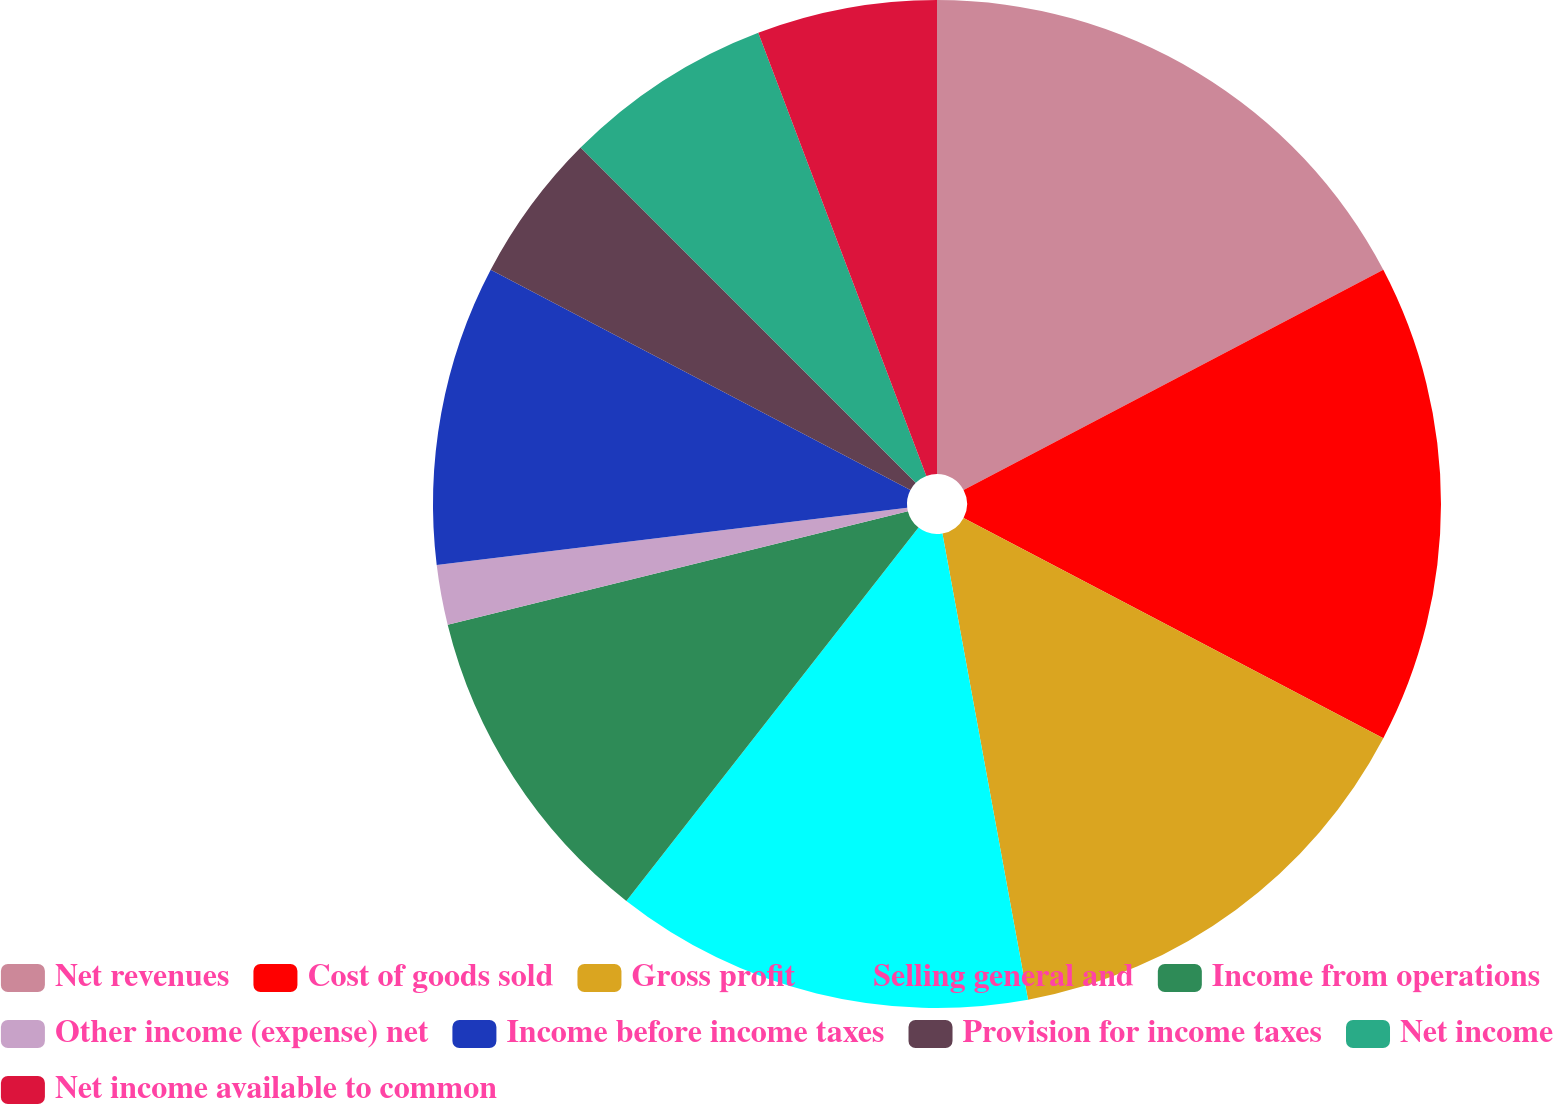<chart> <loc_0><loc_0><loc_500><loc_500><pie_chart><fcel>Net revenues<fcel>Cost of goods sold<fcel>Gross profit<fcel>Selling general and<fcel>Income from operations<fcel>Other income (expense) net<fcel>Income before income taxes<fcel>Provision for income taxes<fcel>Net income<fcel>Net income available to common<nl><fcel>17.31%<fcel>15.38%<fcel>14.42%<fcel>13.46%<fcel>10.58%<fcel>1.92%<fcel>9.62%<fcel>4.81%<fcel>6.73%<fcel>5.77%<nl></chart> 